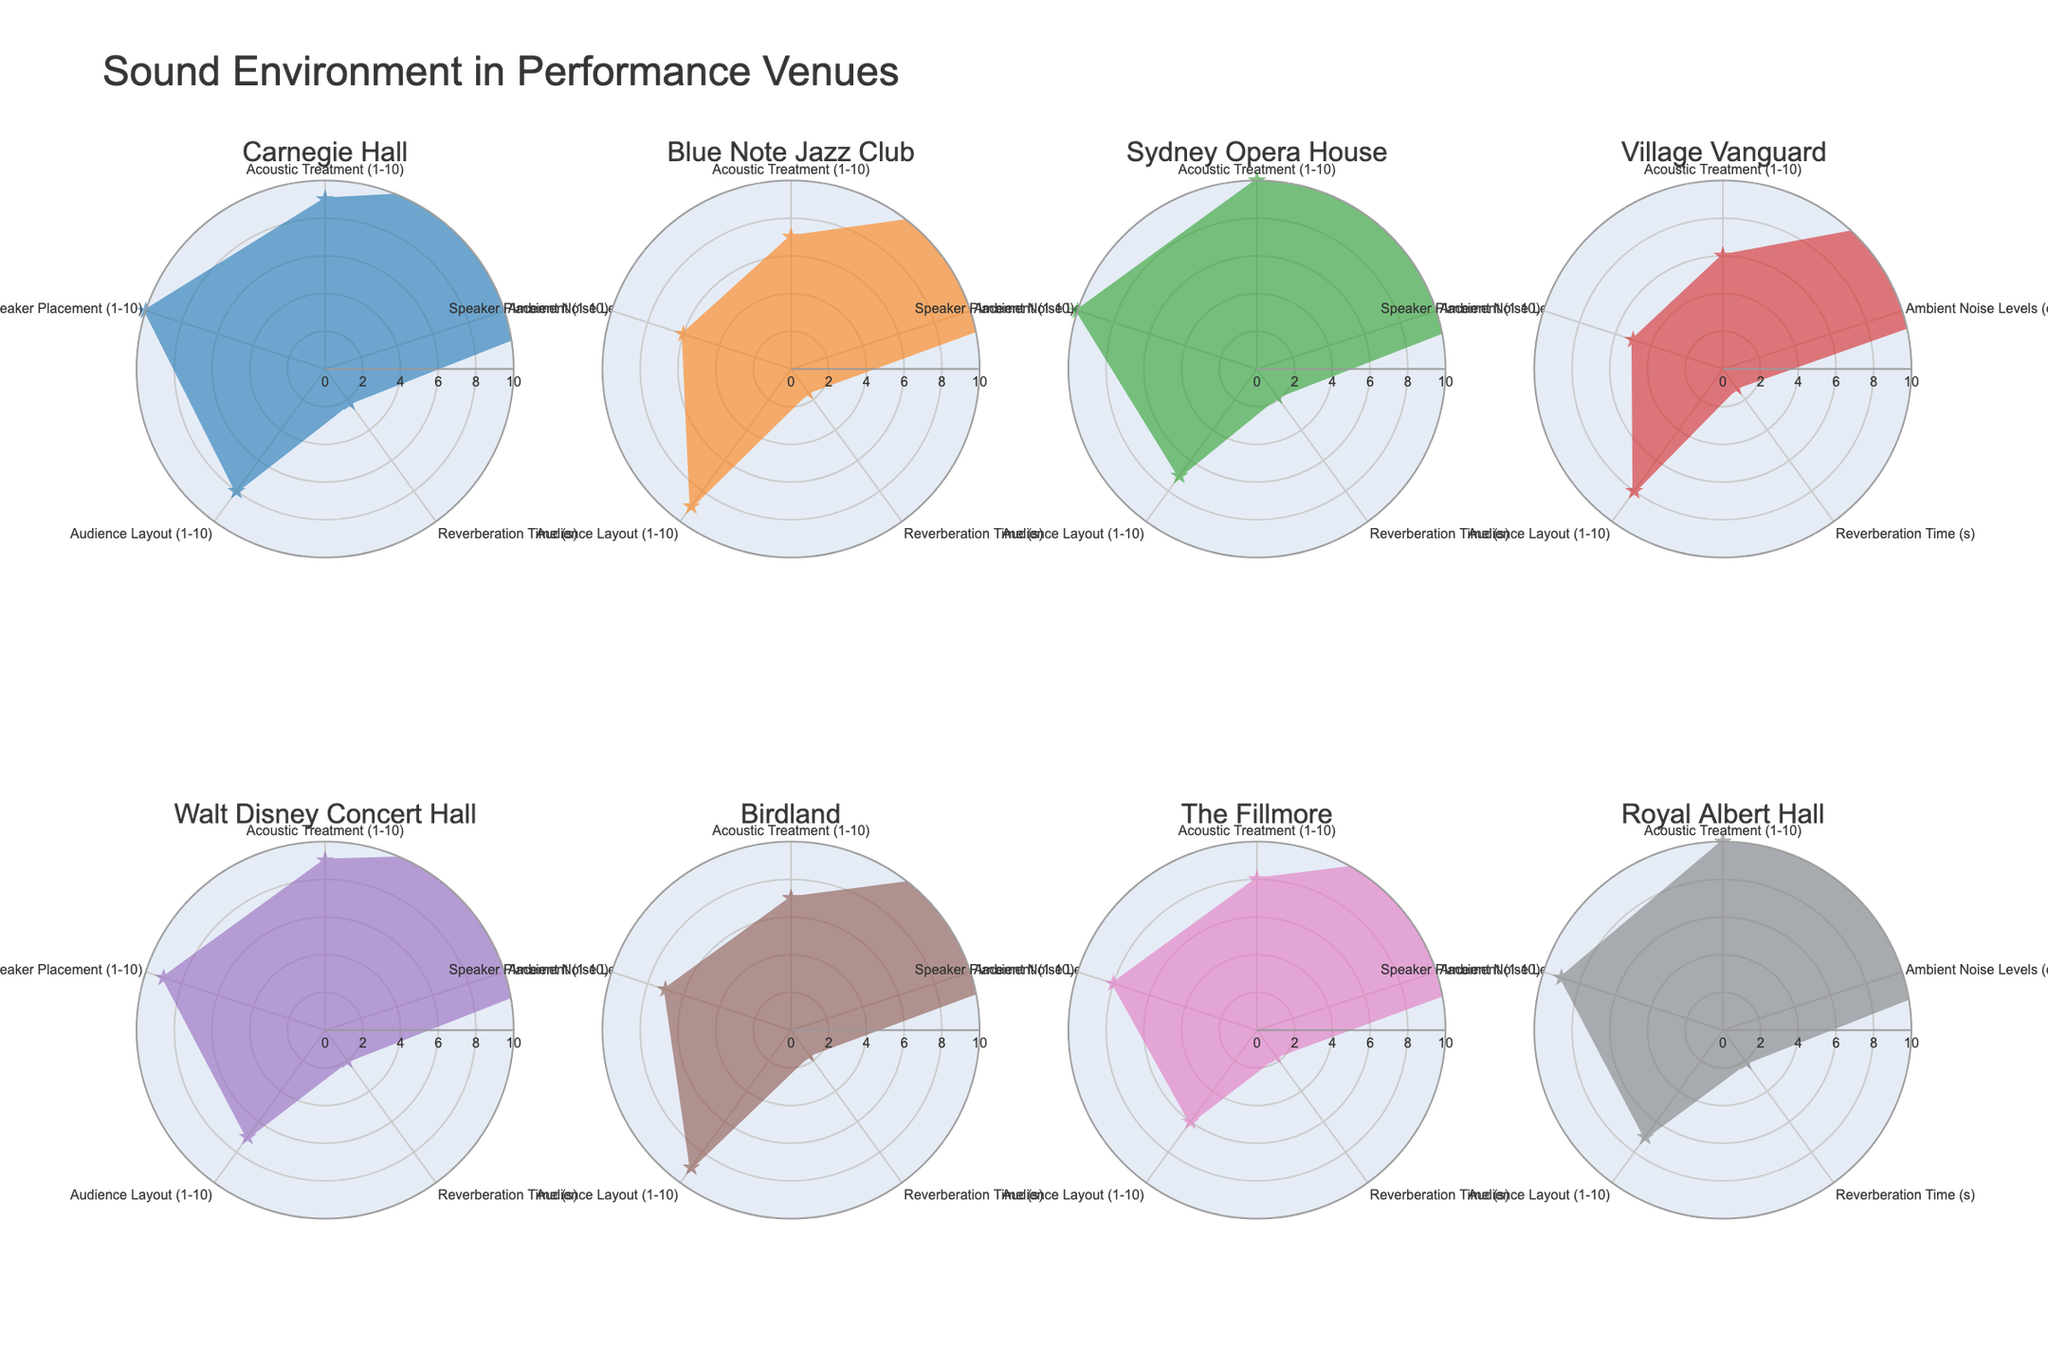What is the highest score for "Acoustic Treatment" across all venues? Check the "Acoustic Treatment" values for all venues. Carnegie Hall, Sydney Opera House, and Royal Albert Hall all have scores of 10, which are the highest.
Answer: 10 How does the "Reverberation Time" of Blue Note Jazz Club compare to Village Vanguard? Blue Note Jazz Club has a "Reverberation Time" of 1.5 seconds, while Village Vanguard has a "Reverberation Time" of 1.2 seconds, so Blue Note Jazz Club has a higher reverberation time.
Answer: Blue Note Jazz Club has a higher reverberation time What is the average "Audience Layout" score among all venues? Add the "Audience Layout" scores: 8 + 9 + 7 + 8 + 7 + 9 + 6 + 7 = 61. Then divide by the number of venues, which is 8. The average is 61/8 = 7.625.
Answer: 7.625 Which venue has the lowest "Ambient Noise Levels"? Check the "Ambient Noise Levels" for all venues. The lowest value is 30 dB at Sydney Opera House.
Answer: Sydney Opera House Is the "Speaker Placement" at Walt Disney Concert Hall higher or lower than at Birdland? Check the "Speaker Placement" values. Walt Disney Concert Hall has a score of 9, while Birdland has a score of 7. Walt Disney Concert Hall has a higher score.
Answer: Higher Which venue has the most balanced scores across all categories? Look at the radar charts to identify which venue's plot is closest to a regular, even shape. Royal Albert Hall scores 10, 33, 2.1, 7, 9, showing high but balanced scores across categories.
Answer: Royal Albert Hall Rank the venues based on their "Reverberation Time" from highest to lowest. Check the "Reverberation Time" for all venues and order them: Carnegie Hall (2.2), Royal Albert Hall (2.1), Walt Disney Concert Hall (2.0), Sydney Opera House (1.8), The Fillmore (1.7), Birdland (1.6), Blue Note Jazz Club (1.5), Village Vanguard (1.2).
Answer: Carnegie Hall, Royal Albert Hall, Walt Disney Concert Hall, Sydney Opera House, The Fillmore, Birdland, Blue Note Jazz Club, Village Vanguard If you were seeking a venue with both high "Acoustic Treatment" and low "Ambient Noise Levels," which one would you choose? Check the values for both "Acoustic Treatment" and "Ambient Noise Levels." Sydney Opera House has the highest "Acoustic Treatment" (10) and the lowest "Ambient Noise Levels" (30 dB).
Answer: Sydney Opera House 